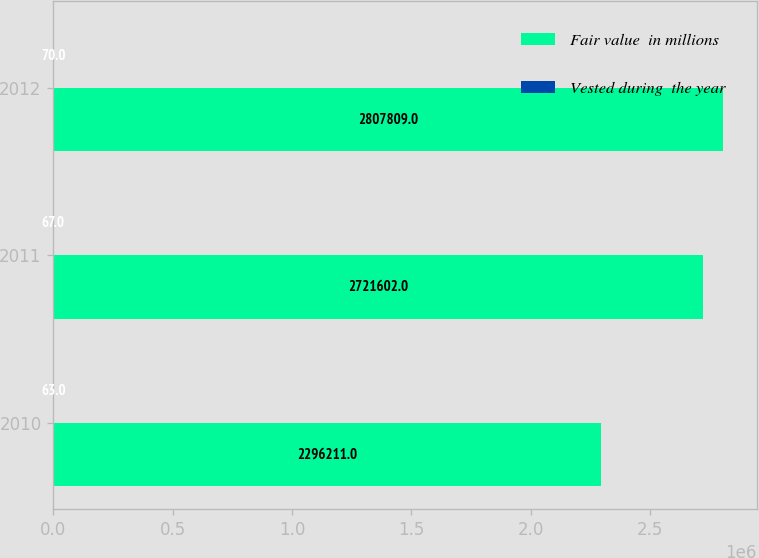<chart> <loc_0><loc_0><loc_500><loc_500><stacked_bar_chart><ecel><fcel>2010<fcel>2011<fcel>2012<nl><fcel>Fair value  in millions<fcel>2.29621e+06<fcel>2.7216e+06<fcel>2.80781e+06<nl><fcel>Vested during  the year<fcel>63<fcel>67<fcel>70<nl></chart> 